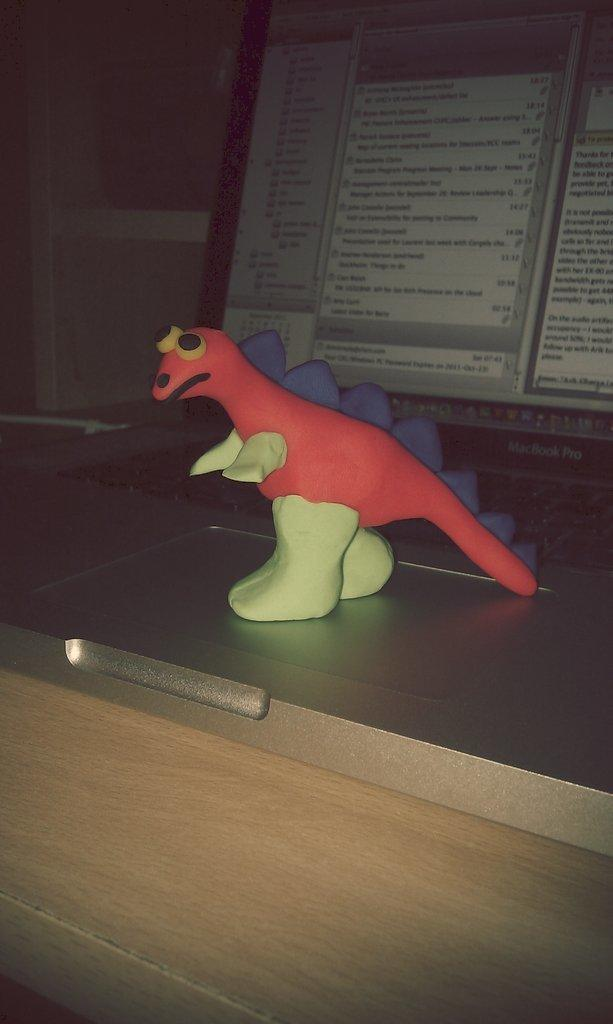What is the main object in the center of the image? There is a toy in the center of the image. What can be seen in the background of the image? There is a computer and a box in the background of the image. What piece of furniture is at the bottom of the image? There is a desk at the bottom of the image. What is the acoustics like in the room depicted in the image? The provided facts do not give any information about the acoustics in the room, so it cannot be determined from the image. 